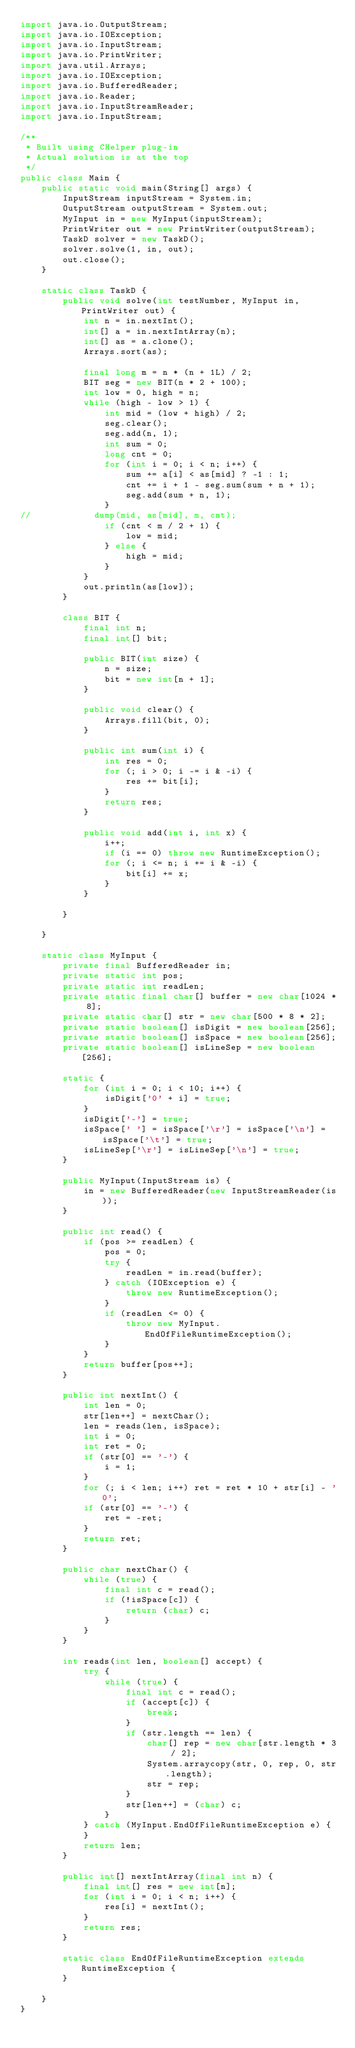<code> <loc_0><loc_0><loc_500><loc_500><_Java_>import java.io.OutputStream;
import java.io.IOException;
import java.io.InputStream;
import java.io.PrintWriter;
import java.util.Arrays;
import java.io.IOException;
import java.io.BufferedReader;
import java.io.Reader;
import java.io.InputStreamReader;
import java.io.InputStream;

/**
 * Built using CHelper plug-in
 * Actual solution is at the top
 */
public class Main {
    public static void main(String[] args) {
        InputStream inputStream = System.in;
        OutputStream outputStream = System.out;
        MyInput in = new MyInput(inputStream);
        PrintWriter out = new PrintWriter(outputStream);
        TaskD solver = new TaskD();
        solver.solve(1, in, out);
        out.close();
    }

    static class TaskD {
        public void solve(int testNumber, MyInput in, PrintWriter out) {
            int n = in.nextInt();
            int[] a = in.nextIntArray(n);
            int[] as = a.clone();
            Arrays.sort(as);

            final long m = n * (n + 1L) / 2;
            BIT seg = new BIT(n * 2 + 100);
            int low = 0, high = n;
            while (high - low > 1) {
                int mid = (low + high) / 2;
                seg.clear();
                seg.add(n, 1);
                int sum = 0;
                long cnt = 0;
                for (int i = 0; i < n; i++) {
                    sum += a[i] < as[mid] ? -1 : 1;
                    cnt += i + 1 - seg.sum(sum + n + 1);
                    seg.add(sum + n, 1);
                }
//            dump(mid, as[mid], m, cnt);
                if (cnt < m / 2 + 1) {
                    low = mid;
                } else {
                    high = mid;
                }
            }
            out.println(as[low]);
        }

        class BIT {
            final int n;
            final int[] bit;

            public BIT(int size) {
                n = size;
                bit = new int[n + 1];
            }

            public void clear() {
                Arrays.fill(bit, 0);
            }

            public int sum(int i) {
                int res = 0;
                for (; i > 0; i -= i & -i) {
                    res += bit[i];
                }
                return res;
            }

            public void add(int i, int x) {
                i++;
                if (i == 0) throw new RuntimeException();
                for (; i <= n; i += i & -i) {
                    bit[i] += x;
                }
            }

        }

    }

    static class MyInput {
        private final BufferedReader in;
        private static int pos;
        private static int readLen;
        private static final char[] buffer = new char[1024 * 8];
        private static char[] str = new char[500 * 8 * 2];
        private static boolean[] isDigit = new boolean[256];
        private static boolean[] isSpace = new boolean[256];
        private static boolean[] isLineSep = new boolean[256];

        static {
            for (int i = 0; i < 10; i++) {
                isDigit['0' + i] = true;
            }
            isDigit['-'] = true;
            isSpace[' '] = isSpace['\r'] = isSpace['\n'] = isSpace['\t'] = true;
            isLineSep['\r'] = isLineSep['\n'] = true;
        }

        public MyInput(InputStream is) {
            in = new BufferedReader(new InputStreamReader(is));
        }

        public int read() {
            if (pos >= readLen) {
                pos = 0;
                try {
                    readLen = in.read(buffer);
                } catch (IOException e) {
                    throw new RuntimeException();
                }
                if (readLen <= 0) {
                    throw new MyInput.EndOfFileRuntimeException();
                }
            }
            return buffer[pos++];
        }

        public int nextInt() {
            int len = 0;
            str[len++] = nextChar();
            len = reads(len, isSpace);
            int i = 0;
            int ret = 0;
            if (str[0] == '-') {
                i = 1;
            }
            for (; i < len; i++) ret = ret * 10 + str[i] - '0';
            if (str[0] == '-') {
                ret = -ret;
            }
            return ret;
        }

        public char nextChar() {
            while (true) {
                final int c = read();
                if (!isSpace[c]) {
                    return (char) c;
                }
            }
        }

        int reads(int len, boolean[] accept) {
            try {
                while (true) {
                    final int c = read();
                    if (accept[c]) {
                        break;
                    }
                    if (str.length == len) {
                        char[] rep = new char[str.length * 3 / 2];
                        System.arraycopy(str, 0, rep, 0, str.length);
                        str = rep;
                    }
                    str[len++] = (char) c;
                }
            } catch (MyInput.EndOfFileRuntimeException e) {
            }
            return len;
        }

        public int[] nextIntArray(final int n) {
            final int[] res = new int[n];
            for (int i = 0; i < n; i++) {
                res[i] = nextInt();
            }
            return res;
        }

        static class EndOfFileRuntimeException extends RuntimeException {
        }

    }
}

</code> 